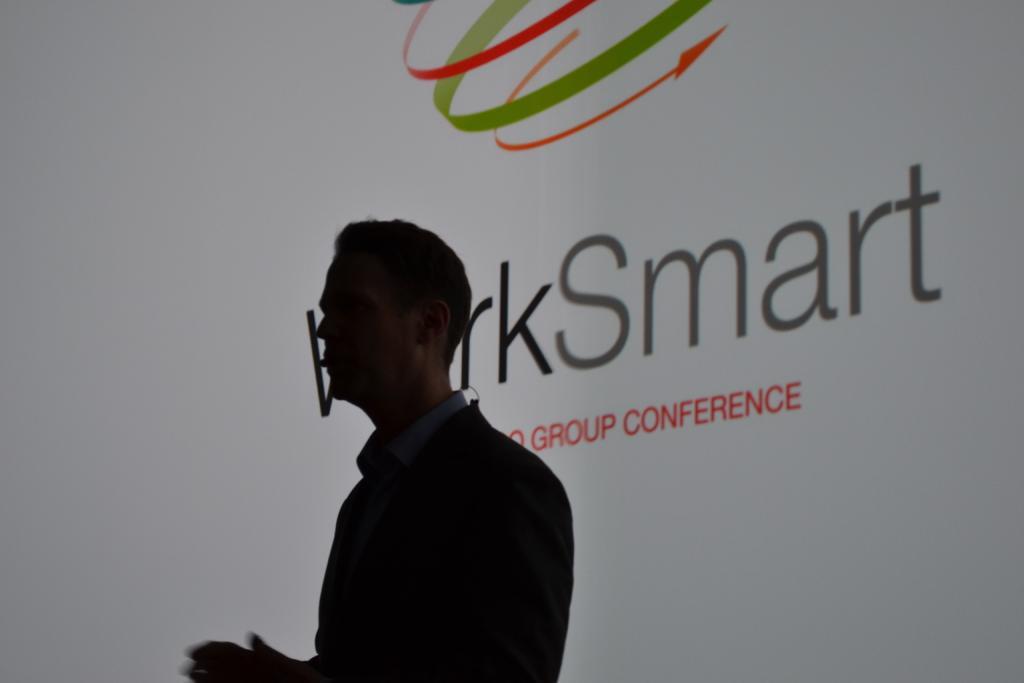How would you summarize this image in a sentence or two? In the picture I can see a person standing and he is in the dark. In the background, I can see the banner or projector screen on which I can see some text. 